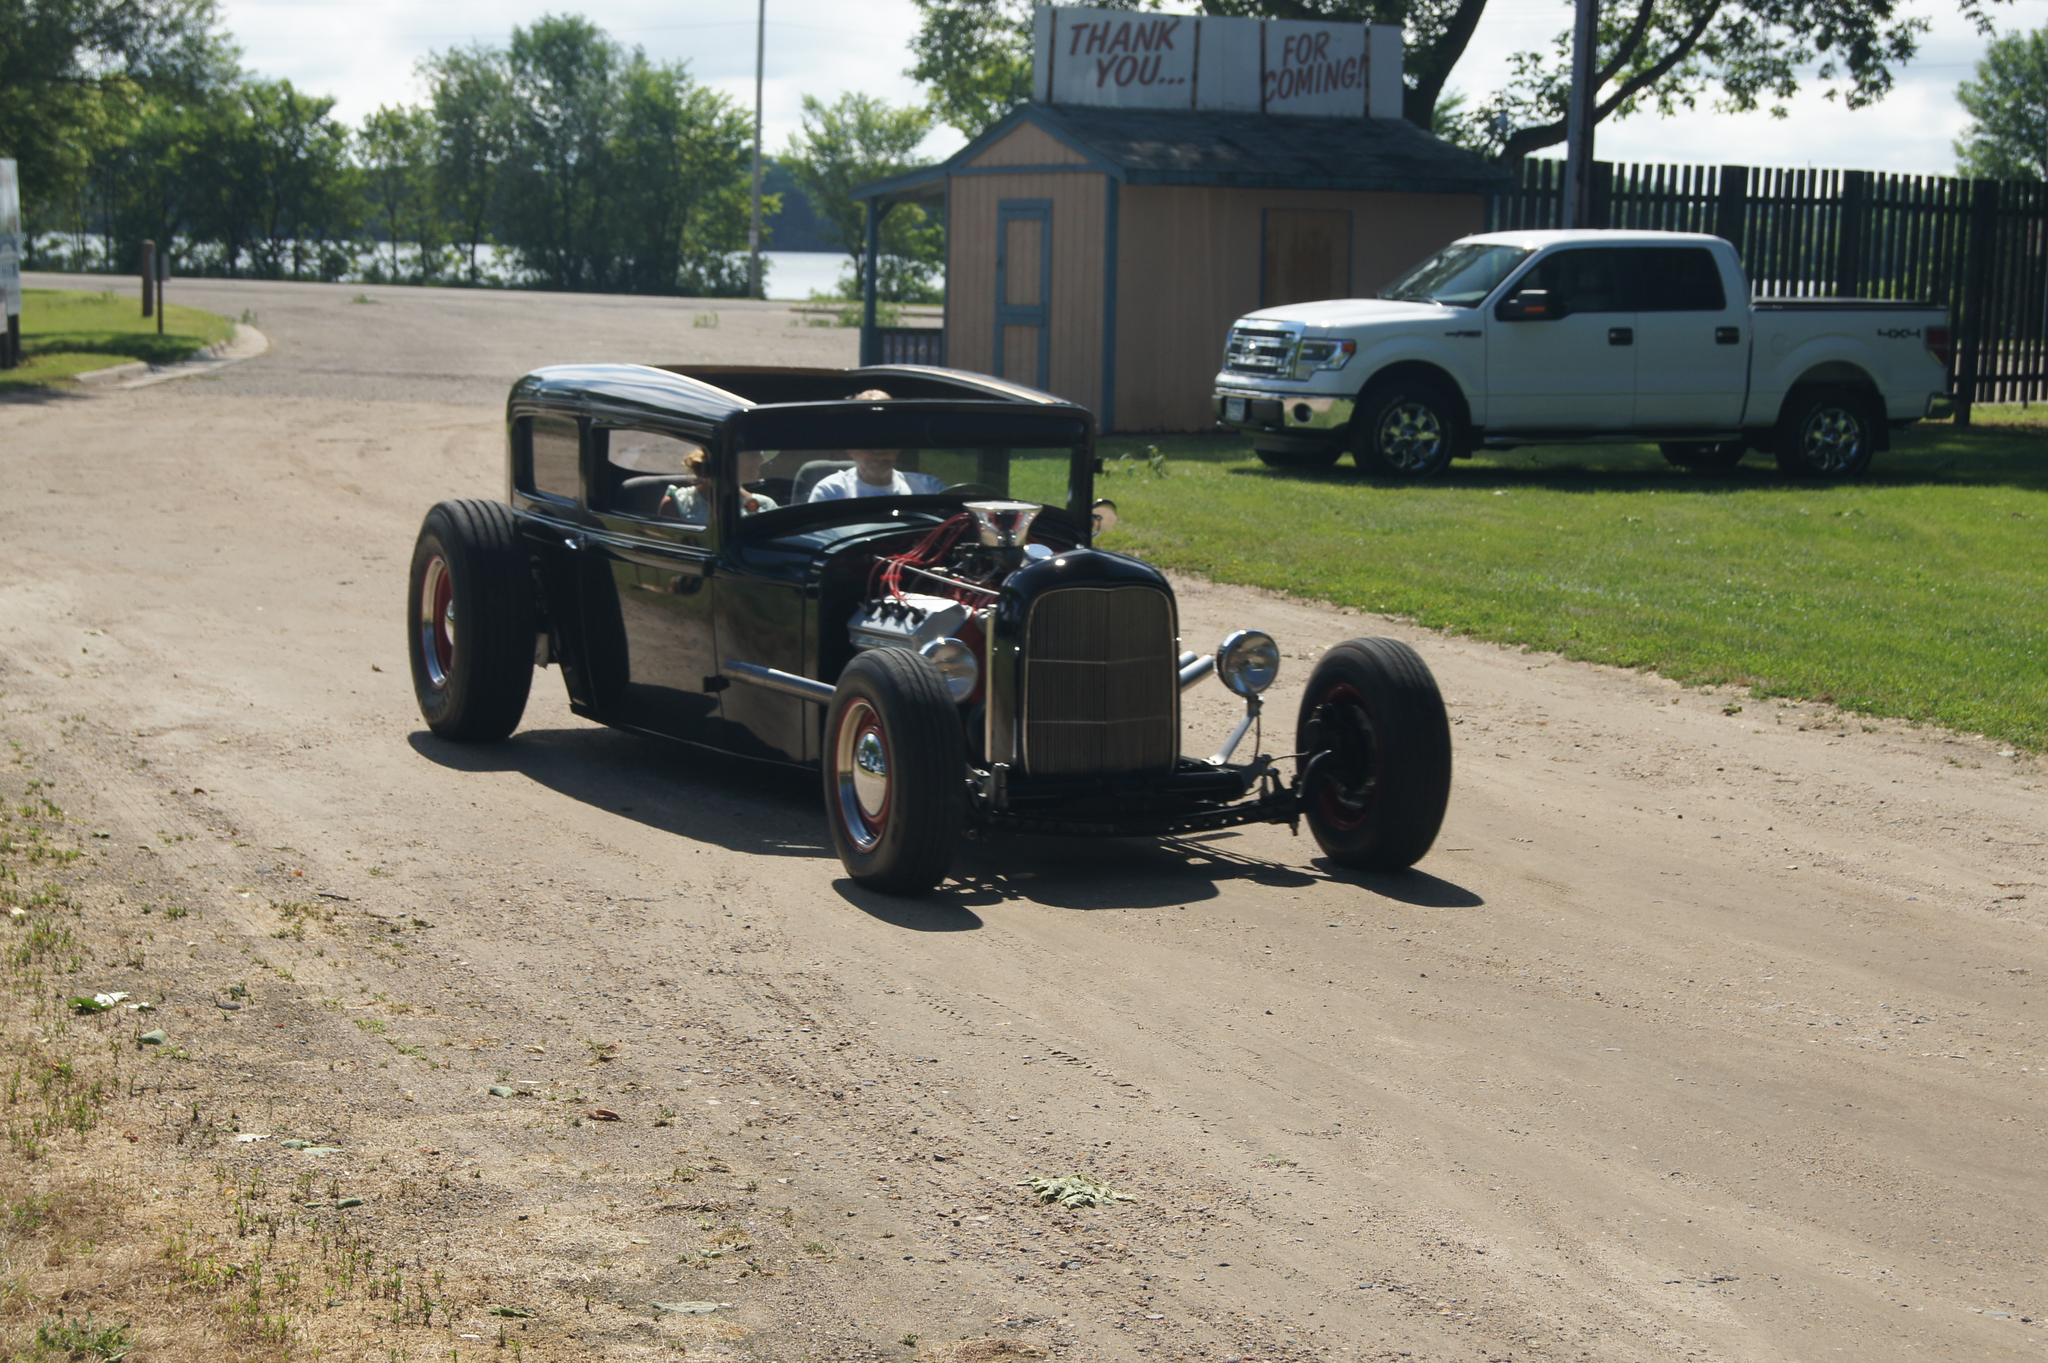Describe this image in one or two sentences. Here we can see two people are riding a vehicle on the road. Background we can see shed, fencing, truck, trees, grass, pole, hoarding and sky. 